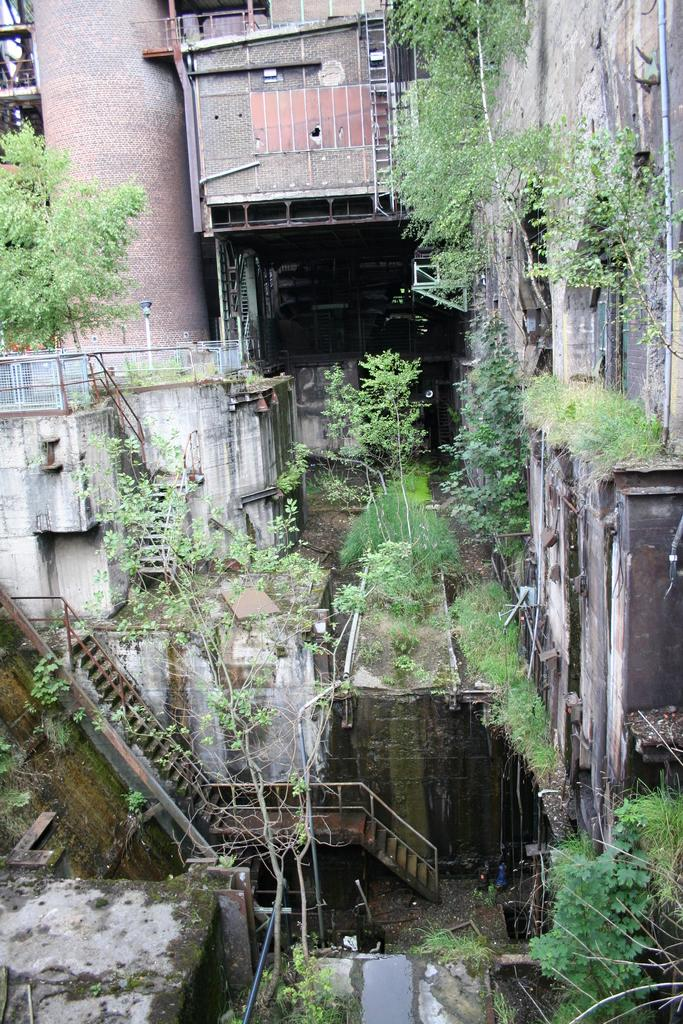What type of structure can be seen in the image? There are staircases, trees, and buildings visible in the image. Can you describe the staircases in the image? The facts provided do not give specific details about the staircases, but we know they are present in the image. What type of natural elements are present in the image? There are trees visible in the image. What type of man-made structures can be seen in the image? There are buildings visible in the image. What type of produce is being harvested in the image? There is no produce visible in the image; it features staircases, trees, and buildings. Can you describe the battle taking place in the image? There is no battle present in the image; it features staircases, trees, and buildings. 